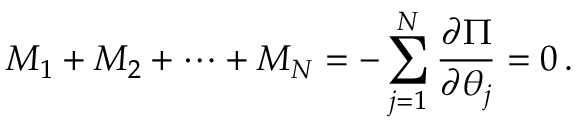Convert formula to latex. <formula><loc_0><loc_0><loc_500><loc_500>M _ { 1 } + M _ { 2 } + \cdots + M _ { N } = - \sum _ { j = 1 } ^ { N } \frac { \partial \Pi } { \partial \theta _ { j } } = 0 \, .</formula> 